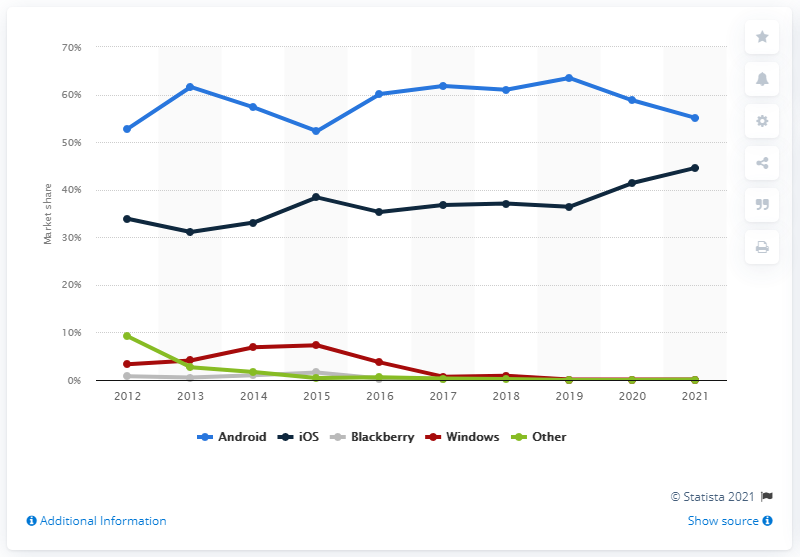Point out several critical features in this image. As of March 2021, the market share of Android in Australia was 55.1%. The market share of iOS has been increasing over the past decade, making it the operating system that has gained the most popularity among users. 